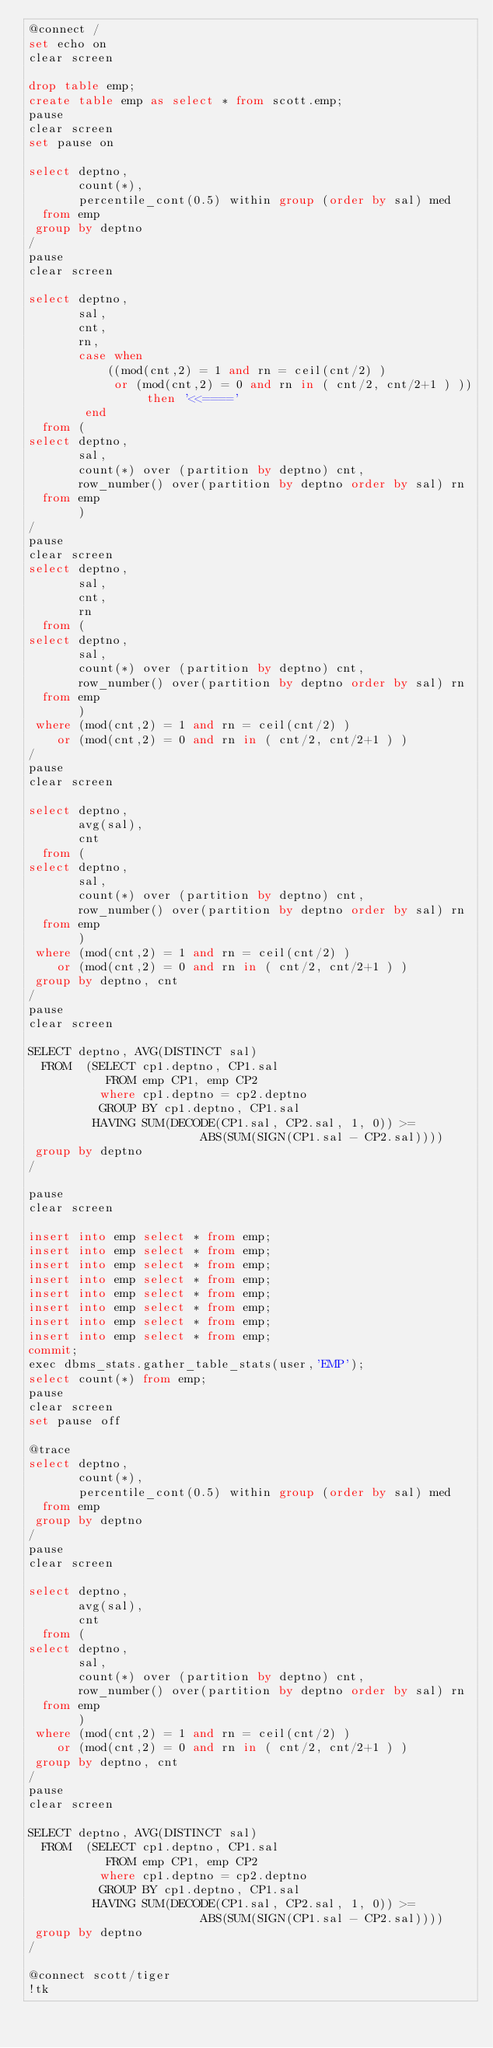<code> <loc_0><loc_0><loc_500><loc_500><_SQL_>@connect /
set echo on
clear screen

drop table emp;
create table emp as select * from scott.emp;
pause
clear screen
set pause on

select deptno,
       count(*),
       percentile_cont(0.5) within group (order by sal) med
  from emp
 group by deptno
/
pause
clear screen

select deptno,
       sal,
       cnt,
       rn,
       case when
           ((mod(cnt,2) = 1 and rn = ceil(cnt/2) )
            or (mod(cnt,2) = 0 and rn in ( cnt/2, cnt/2+1 ) )) then '<<===='
        end
  from (
select deptno,
       sal,
       count(*) over (partition by deptno) cnt,
       row_number() over(partition by deptno order by sal) rn
  from emp
       )
/
pause
clear screen
select deptno,
       sal,
       cnt,
       rn
  from (
select deptno,
       sal,
       count(*) over (partition by deptno) cnt,
       row_number() over(partition by deptno order by sal) rn
  from emp
       )
 where (mod(cnt,2) = 1 and rn = ceil(cnt/2) )
    or (mod(cnt,2) = 0 and rn in ( cnt/2, cnt/2+1 ) )
/
pause
clear screen

select deptno,
       avg(sal),
       cnt
  from (
select deptno,
       sal,
       count(*) over (partition by deptno) cnt,
       row_number() over(partition by deptno order by sal) rn
  from emp
       )
 where (mod(cnt,2) = 1 and rn = ceil(cnt/2) )
    or (mod(cnt,2) = 0 and rn in ( cnt/2, cnt/2+1 ) )
 group by deptno, cnt
/
pause
clear screen

SELECT deptno, AVG(DISTINCT sal)
  FROM  (SELECT cp1.deptno, CP1.sal
           FROM emp CP1, emp CP2
          where cp1.deptno = cp2.deptno
          GROUP BY cp1.deptno, CP1.sal
         HAVING SUM(DECODE(CP1.sal, CP2.sal, 1, 0)) >=
                        ABS(SUM(SIGN(CP1.sal - CP2.sal))))
 group by deptno
/

pause
clear screen

insert into emp select * from emp;
insert into emp select * from emp;
insert into emp select * from emp;
insert into emp select * from emp;
insert into emp select * from emp;
insert into emp select * from emp;
insert into emp select * from emp;
insert into emp select * from emp;
commit;
exec dbms_stats.gather_table_stats(user,'EMP');
select count(*) from emp;
pause
clear screen
set pause off

@trace
select deptno,
       count(*),
       percentile_cont(0.5) within group (order by sal) med
  from emp
 group by deptno
/
pause
clear screen

select deptno,
       avg(sal),
       cnt
  from (
select deptno,
       sal,
       count(*) over (partition by deptno) cnt,
       row_number() over(partition by deptno order by sal) rn
  from emp
       )
 where (mod(cnt,2) = 1 and rn = ceil(cnt/2) )
    or (mod(cnt,2) = 0 and rn in ( cnt/2, cnt/2+1 ) )
 group by deptno, cnt
/
pause
clear screen

SELECT deptno, AVG(DISTINCT sal)
  FROM  (SELECT cp1.deptno, CP1.sal
           FROM emp CP1, emp CP2
          where cp1.deptno = cp2.deptno
          GROUP BY cp1.deptno, CP1.sal
         HAVING SUM(DECODE(CP1.sal, CP2.sal, 1, 0)) >=
                        ABS(SUM(SIGN(CP1.sal - CP2.sal))))
 group by deptno
/

@connect scott/tiger
!tk

</code> 